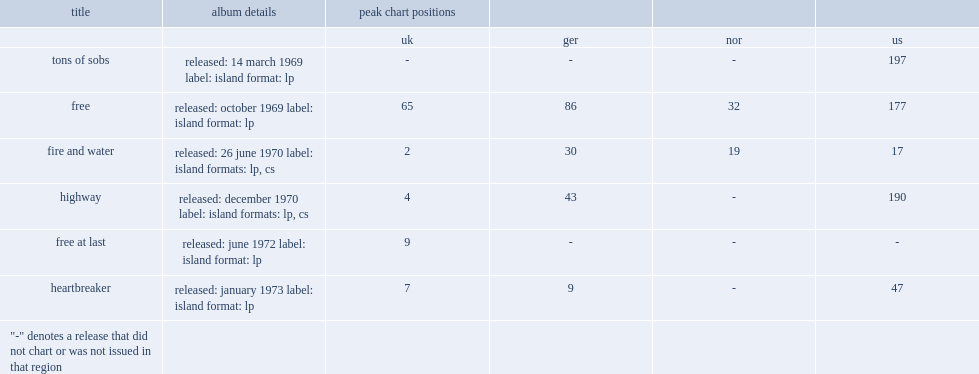What was the peak chart position on the us of tons of sobs? 197.0. 